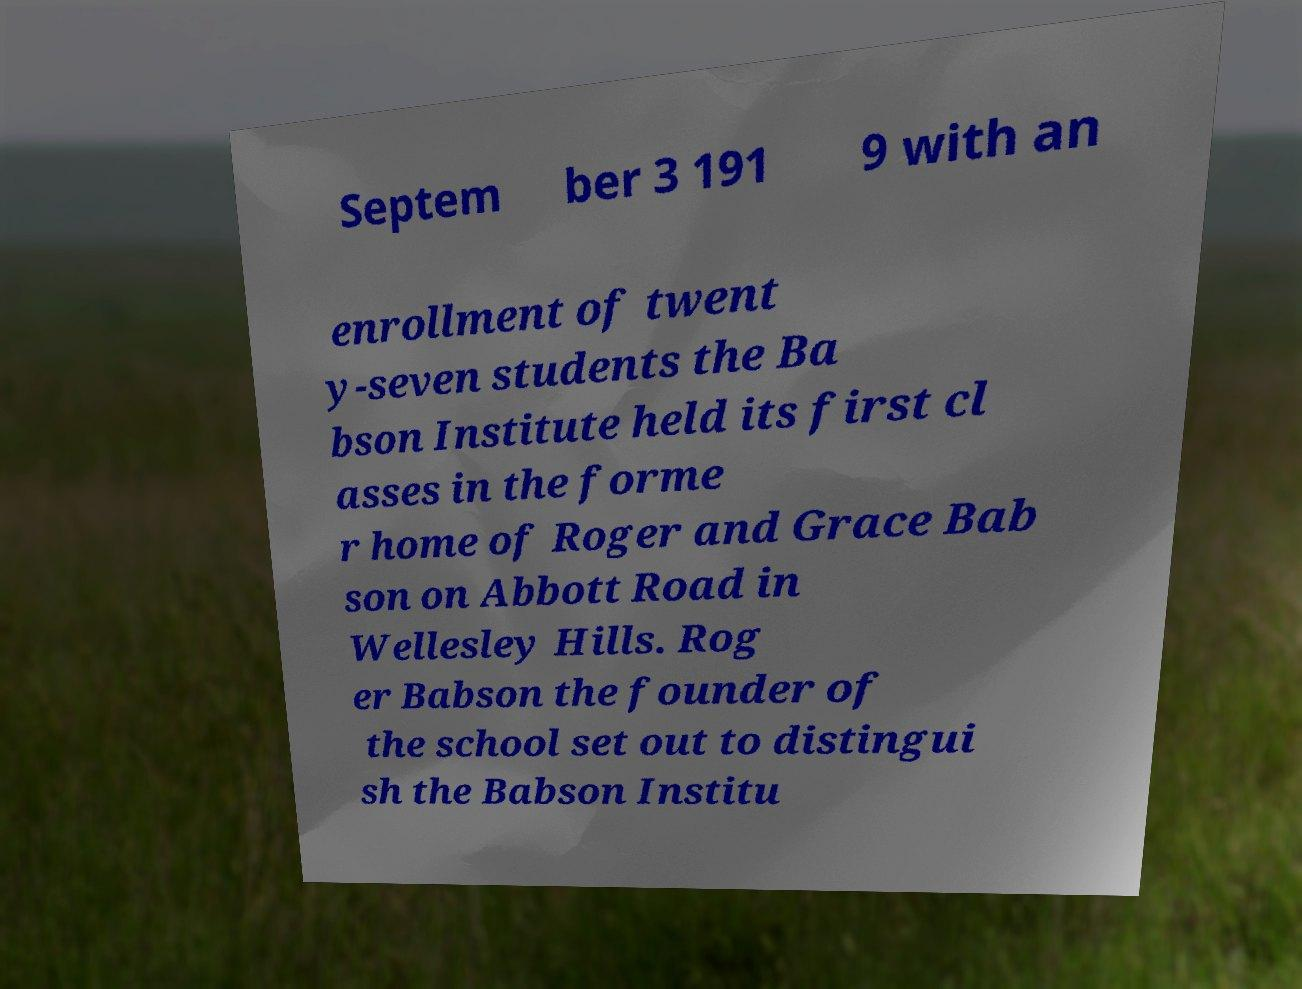For documentation purposes, I need the text within this image transcribed. Could you provide that? Septem ber 3 191 9 with an enrollment of twent y-seven students the Ba bson Institute held its first cl asses in the forme r home of Roger and Grace Bab son on Abbott Road in Wellesley Hills. Rog er Babson the founder of the school set out to distingui sh the Babson Institu 